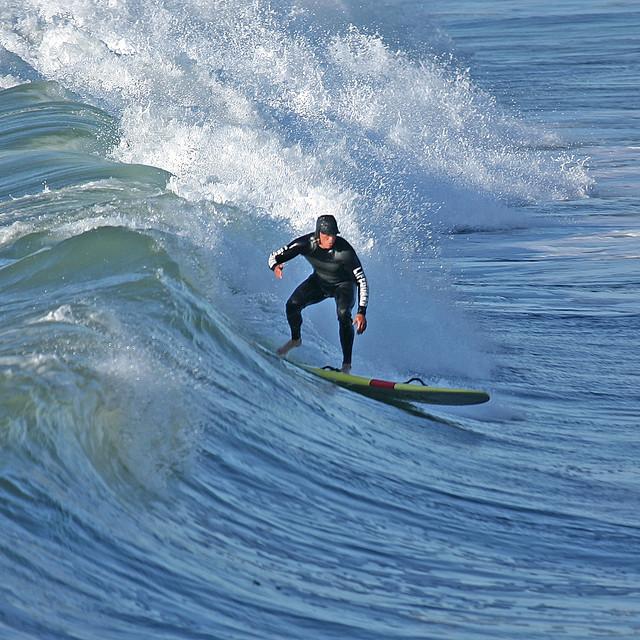Where is the man heading?
Quick response, please. To shore. What is the man doing?
Answer briefly. Surfing. Where is the surfboard?
Quick response, please. On water. 